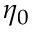<formula> <loc_0><loc_0><loc_500><loc_500>\eta _ { 0 }</formula> 